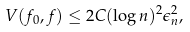<formula> <loc_0><loc_0><loc_500><loc_500>V ( f _ { 0 } , f ) \leq 2 C ( \log n ) ^ { 2 } \epsilon _ { n } ^ { 2 } ,</formula> 